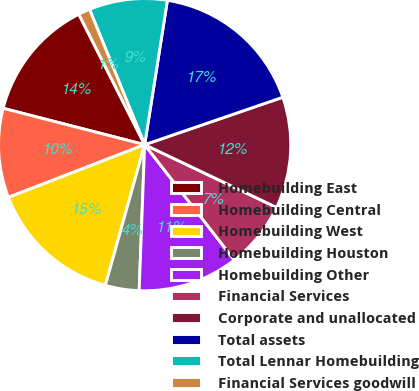Convert chart. <chart><loc_0><loc_0><loc_500><loc_500><pie_chart><fcel>Homebuilding East<fcel>Homebuilding Central<fcel>Homebuilding West<fcel>Homebuilding Houston<fcel>Homebuilding Other<fcel>Financial Services<fcel>Corporate and unallocated<fcel>Total assets<fcel>Total Lennar Homebuilding<fcel>Financial Services goodwill<nl><fcel>13.56%<fcel>9.88%<fcel>14.79%<fcel>3.74%<fcel>11.11%<fcel>7.42%<fcel>12.33%<fcel>17.25%<fcel>8.65%<fcel>1.28%<nl></chart> 